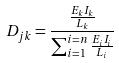<formula> <loc_0><loc_0><loc_500><loc_500>D _ { j k } = \frac { \frac { E _ { k } I _ { k } } { L _ { k } } } { \sum _ { i = 1 } ^ { i = n } \frac { E _ { i } I _ { i } } { L _ { i } } }</formula> 